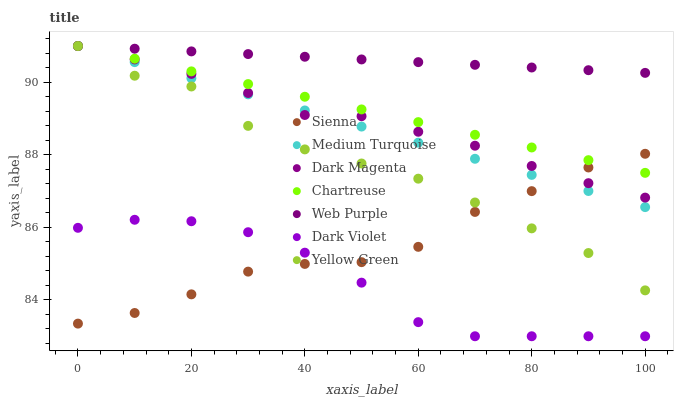Does Dark Violet have the minimum area under the curve?
Answer yes or no. Yes. Does Web Purple have the maximum area under the curve?
Answer yes or no. Yes. Does Chartreuse have the minimum area under the curve?
Answer yes or no. No. Does Chartreuse have the maximum area under the curve?
Answer yes or no. No. Is Medium Turquoise the smoothest?
Answer yes or no. Yes. Is Yellow Green the roughest?
Answer yes or no. Yes. Is Chartreuse the smoothest?
Answer yes or no. No. Is Chartreuse the roughest?
Answer yes or no. No. Does Dark Violet have the lowest value?
Answer yes or no. Yes. Does Chartreuse have the lowest value?
Answer yes or no. No. Does Yellow Green have the highest value?
Answer yes or no. Yes. Does Dark Violet have the highest value?
Answer yes or no. No. Is Dark Violet less than Yellow Green?
Answer yes or no. Yes. Is Web Purple greater than Dark Violet?
Answer yes or no. Yes. Does Yellow Green intersect Medium Turquoise?
Answer yes or no. Yes. Is Yellow Green less than Medium Turquoise?
Answer yes or no. No. Is Yellow Green greater than Medium Turquoise?
Answer yes or no. No. Does Dark Violet intersect Yellow Green?
Answer yes or no. No. 